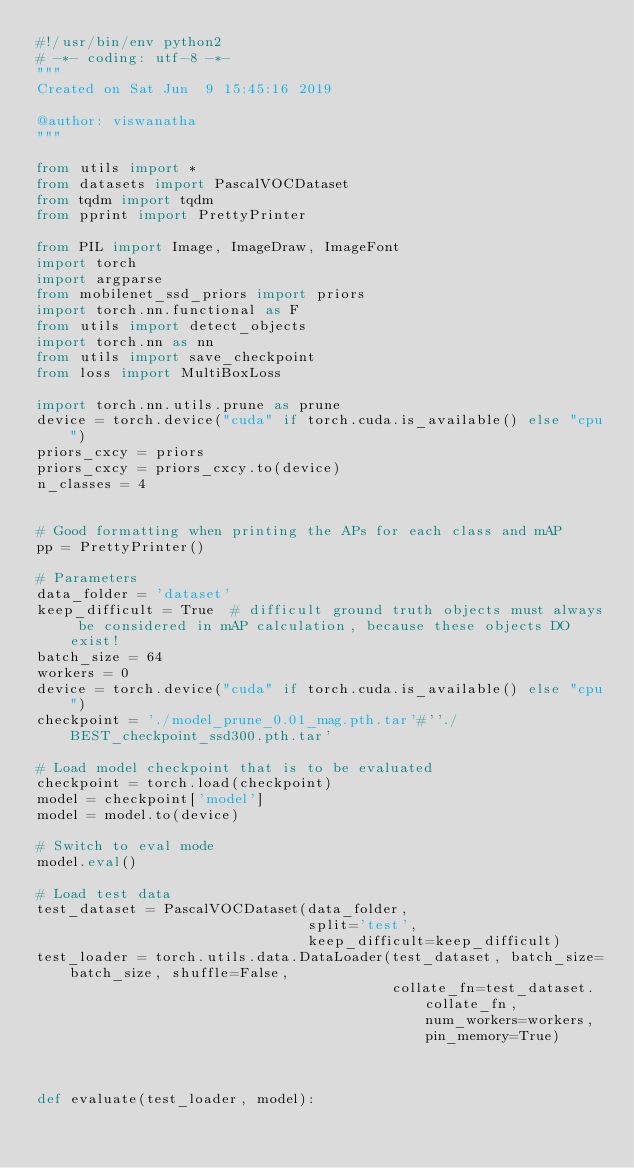<code> <loc_0><loc_0><loc_500><loc_500><_Python_>#!/usr/bin/env python2
# -*- coding: utf-8 -*-
"""
Created on Sat Jun  9 15:45:16 2019

@author: viswanatha
"""

from utils import *
from datasets import PascalVOCDataset
from tqdm import tqdm
from pprint import PrettyPrinter

from PIL import Image, ImageDraw, ImageFont
import torch
import argparse
from mobilenet_ssd_priors import priors
import torch.nn.functional as F
from utils import detect_objects
import torch.nn as nn
from utils import save_checkpoint
from loss import MultiBoxLoss

import torch.nn.utils.prune as prune
device = torch.device("cuda" if torch.cuda.is_available() else "cpu")
priors_cxcy = priors
priors_cxcy = priors_cxcy.to(device)
n_classes = 4


# Good formatting when printing the APs for each class and mAP
pp = PrettyPrinter()

# Parameters
data_folder = 'dataset'
keep_difficult = True  # difficult ground truth objects must always be considered in mAP calculation, because these objects DO exist!
batch_size = 64
workers = 0
device = torch.device("cuda" if torch.cuda.is_available() else "cpu")
checkpoint = './model_prune_0.01_mag.pth.tar'#''./BEST_checkpoint_ssd300.pth.tar'

# Load model checkpoint that is to be evaluated
checkpoint = torch.load(checkpoint)
model = checkpoint['model']
model = model.to(device)

# Switch to eval mode
model.eval()

# Load test data
test_dataset = PascalVOCDataset(data_folder,
                                split='test',
                                keep_difficult=keep_difficult)
test_loader = torch.utils.data.DataLoader(test_dataset, batch_size=batch_size, shuffle=False,
                                          collate_fn=test_dataset.collate_fn, num_workers=workers, pin_memory=True)



def evaluate(test_loader, model):</code> 